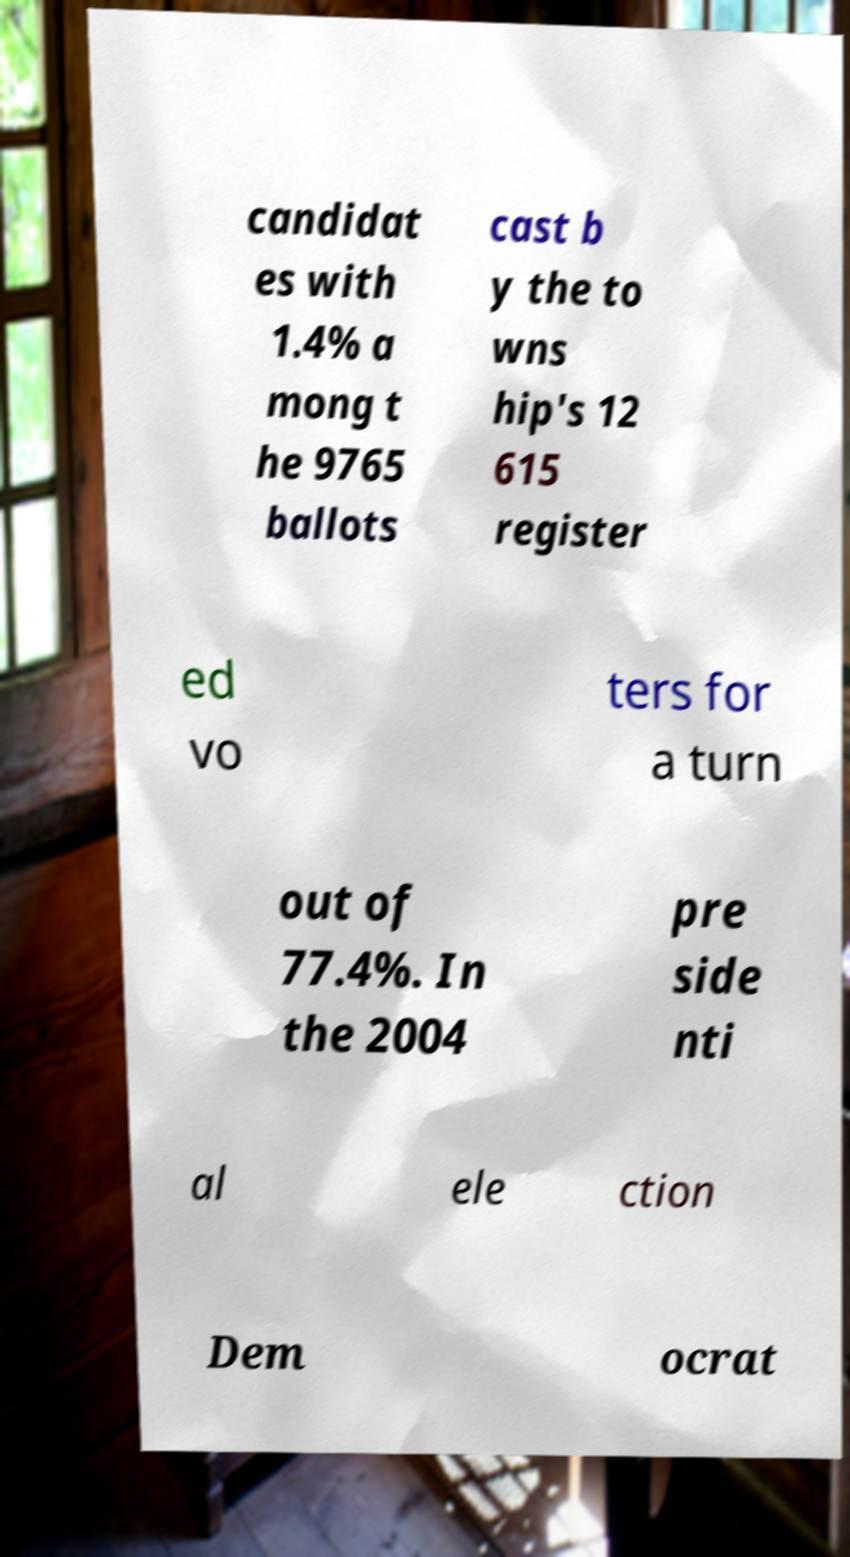Could you assist in decoding the text presented in this image and type it out clearly? candidat es with 1.4% a mong t he 9765 ballots cast b y the to wns hip's 12 615 register ed vo ters for a turn out of 77.4%. In the 2004 pre side nti al ele ction Dem ocrat 